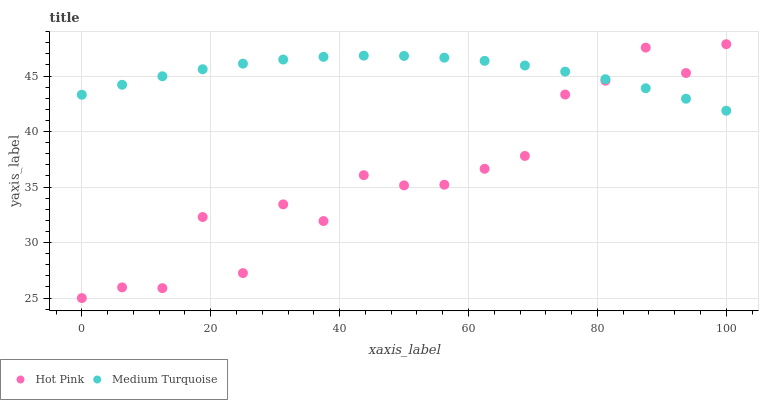Does Hot Pink have the minimum area under the curve?
Answer yes or no. Yes. Does Medium Turquoise have the maximum area under the curve?
Answer yes or no. Yes. Does Medium Turquoise have the minimum area under the curve?
Answer yes or no. No. Is Medium Turquoise the smoothest?
Answer yes or no. Yes. Is Hot Pink the roughest?
Answer yes or no. Yes. Is Medium Turquoise the roughest?
Answer yes or no. No. Does Hot Pink have the lowest value?
Answer yes or no. Yes. Does Medium Turquoise have the lowest value?
Answer yes or no. No. Does Hot Pink have the highest value?
Answer yes or no. Yes. Does Medium Turquoise have the highest value?
Answer yes or no. No. Does Medium Turquoise intersect Hot Pink?
Answer yes or no. Yes. Is Medium Turquoise less than Hot Pink?
Answer yes or no. No. Is Medium Turquoise greater than Hot Pink?
Answer yes or no. No. 